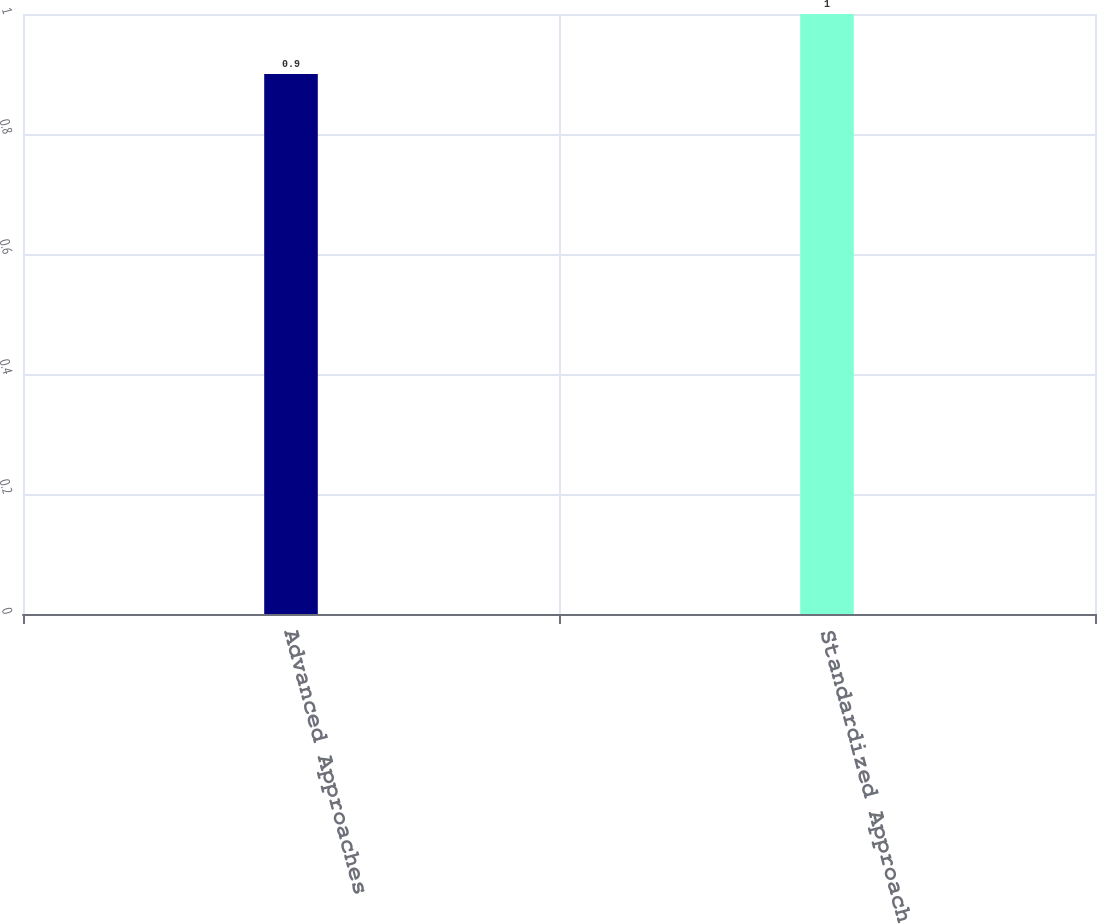Convert chart. <chart><loc_0><loc_0><loc_500><loc_500><bar_chart><fcel>Advanced Approaches<fcel>Standardized Approach<nl><fcel>0.9<fcel>1<nl></chart> 